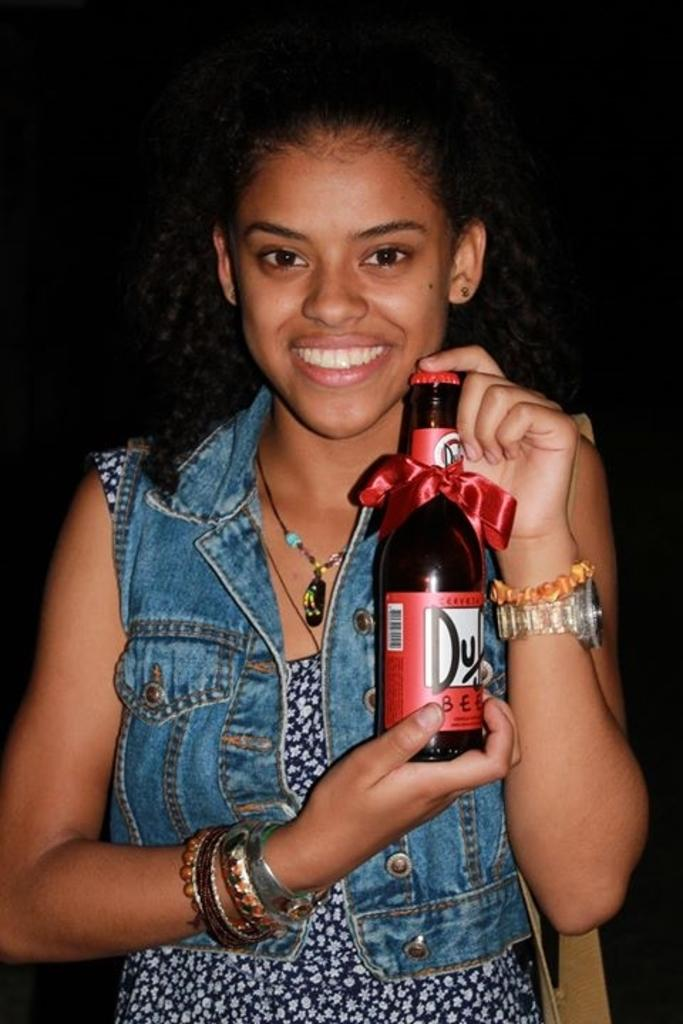Who is the main subject in the image? There is a woman in the image. What is the woman holding in the image? The woman is holding a bottle. What type of clothing is the woman wearing? The woman is wearing a jeans jacket. What can be observed about the background of the image? The background of the image is dark. What type of shoes is the maid wearing in the image? There is no maid present in the image, and therefore no shoes to describe. 